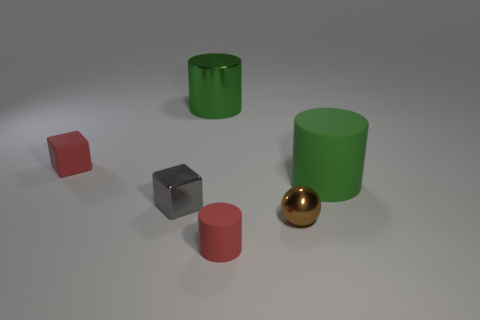Can you tell which object stands out the most and why? The shiny golden sphere stands out the most due to its reflective surface and distinct color, which contrasts with the matte textures and less vibrant colors of the other objects. Why do you think the sphere was designed to be reflective? In a 3D rendering or artistic composition, a reflective sphere might be used to showcase the capability of the rendering software to simulate different materials and lighting effects, creating a visually interesting and dynamic element within the scene. 